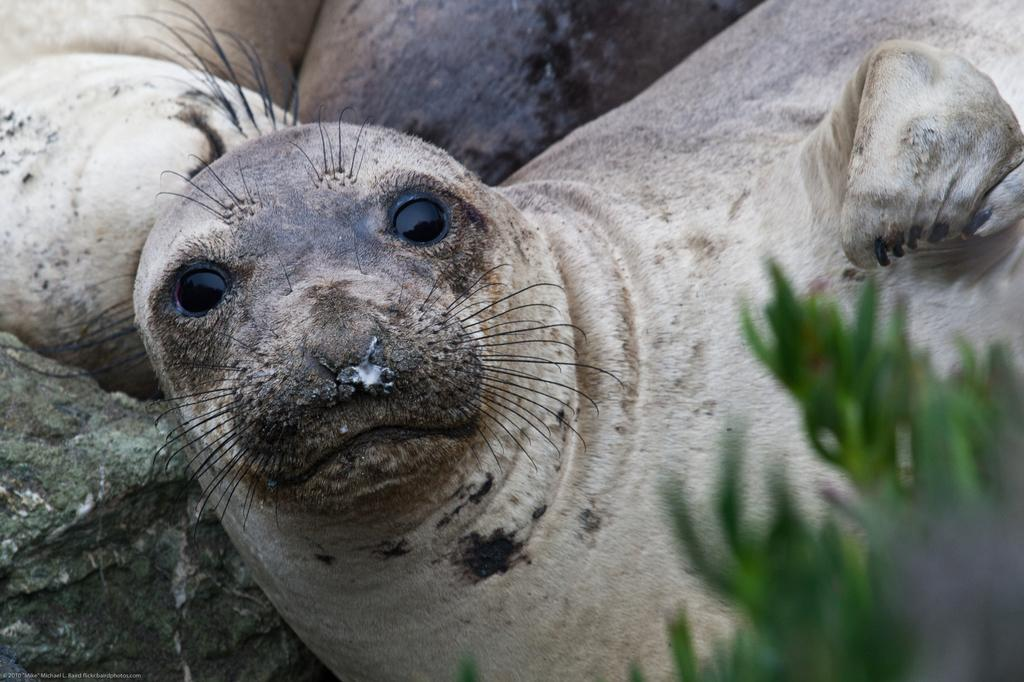What types of living organisms can be seen in the image? There are animals in the image. Can you describe any other objects or features in the image? Yes, there is a rock in the bottom left of the image and a plant in the bottom right of the image. What type of smoke can be seen coming from the animals in the image? There is no smoke present in the image; it features animals, a rock, and a plant. How do the animals show respect to each other in the image? There is no indication in the image that the animals are showing respect to each other, as their actions or behaviors are not described. 